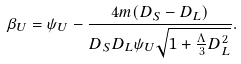Convert formula to latex. <formula><loc_0><loc_0><loc_500><loc_500>\beta _ { U } = \psi _ { U } - \frac { 4 m ( D _ { S } - D _ { L } ) } { D _ { S } D _ { L } \psi _ { U } \sqrt { 1 + \frac { \Lambda } { 3 } D _ { L } ^ { 2 } } } .</formula> 